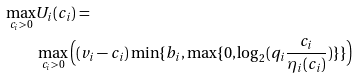<formula> <loc_0><loc_0><loc_500><loc_500>\max _ { c _ { i } > 0 } & U _ { i } ( c _ { i } ) = \\ & \max _ { c _ { i } > 0 } \Big { ( } ( v _ { i } - c _ { i } ) \min \{ b _ { i } , \max \{ 0 , \log _ { 2 } ( { q _ { i } \frac { c _ { i } } { { \eta } _ { i } ( c _ { i } ) } } ) \} \} \Big { ) }</formula> 